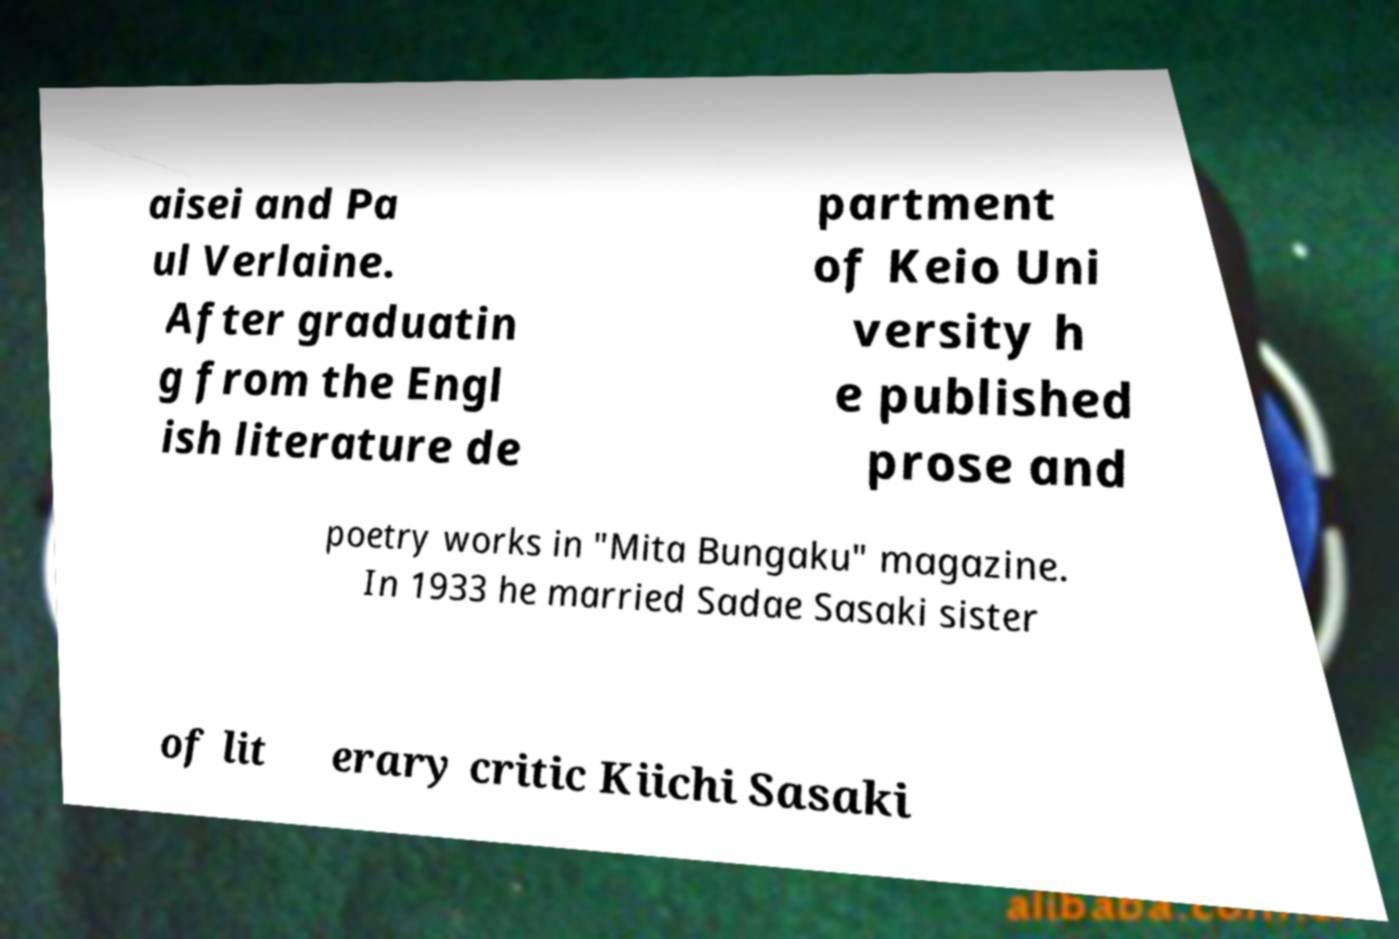Could you assist in decoding the text presented in this image and type it out clearly? aisei and Pa ul Verlaine. After graduatin g from the Engl ish literature de partment of Keio Uni versity h e published prose and poetry works in "Mita Bungaku" magazine. In 1933 he married Sadae Sasaki sister of lit erary critic Kiichi Sasaki 